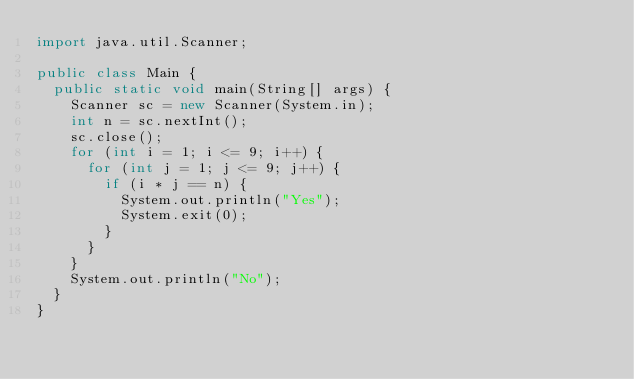Convert code to text. <code><loc_0><loc_0><loc_500><loc_500><_Java_>import java.util.Scanner;

public class Main {
	public static void main(String[] args) {
		Scanner sc = new Scanner(System.in);
		int n = sc.nextInt();
		sc.close(); 
		for (int i = 1; i <= 9; i++) {
			for (int j = 1; j <= 9; j++) {
				if (i * j == n) {
					System.out.println("Yes");
					System.exit(0);
				}				
			}
		}
		System.out.println("No");
	}
}</code> 